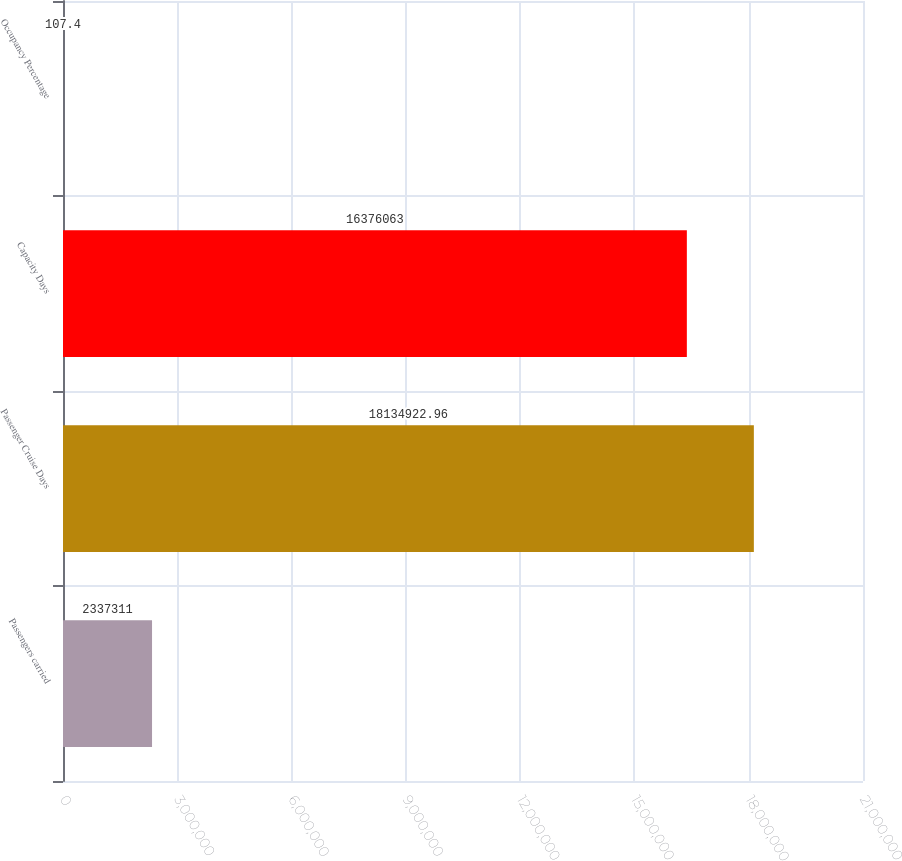Convert chart. <chart><loc_0><loc_0><loc_500><loc_500><bar_chart><fcel>Passengers carried<fcel>Passenger Cruise Days<fcel>Capacity Days<fcel>Occupancy Percentage<nl><fcel>2.33731e+06<fcel>1.81349e+07<fcel>1.63761e+07<fcel>107.4<nl></chart> 